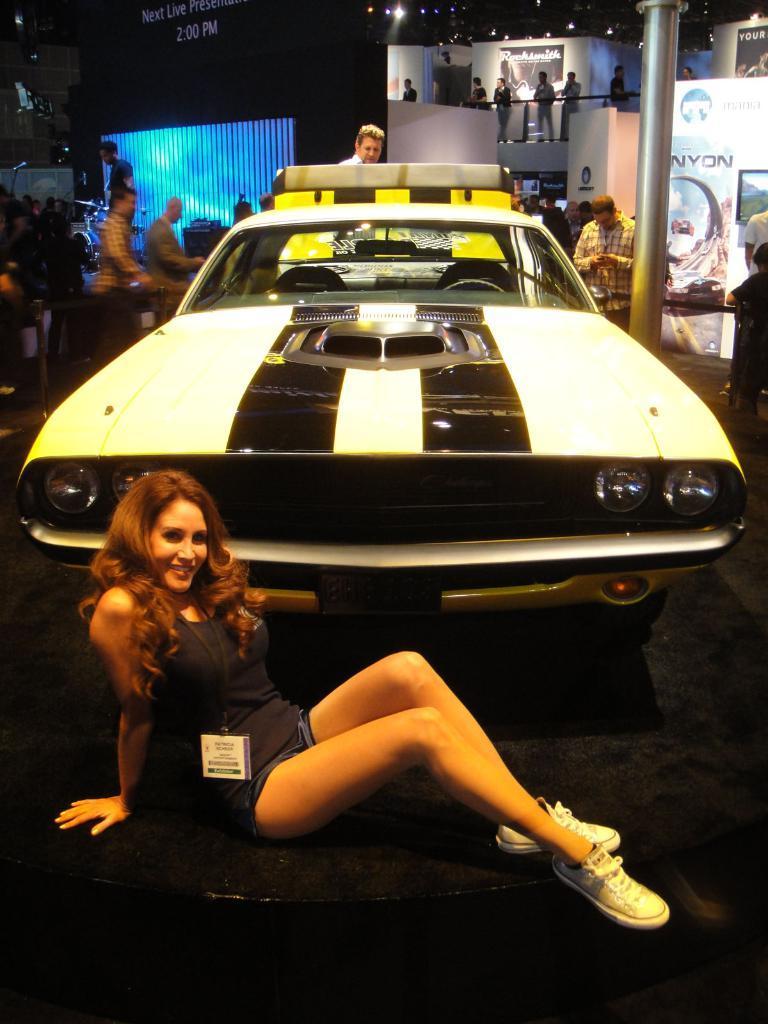Could you give a brief overview of what you see in this image? In the center of the image a car is there. At the bottom of the image a lady is sitting on the floor. In the background of the image we can see some people there. At the top of the image lights, board, pole, wall are present. 